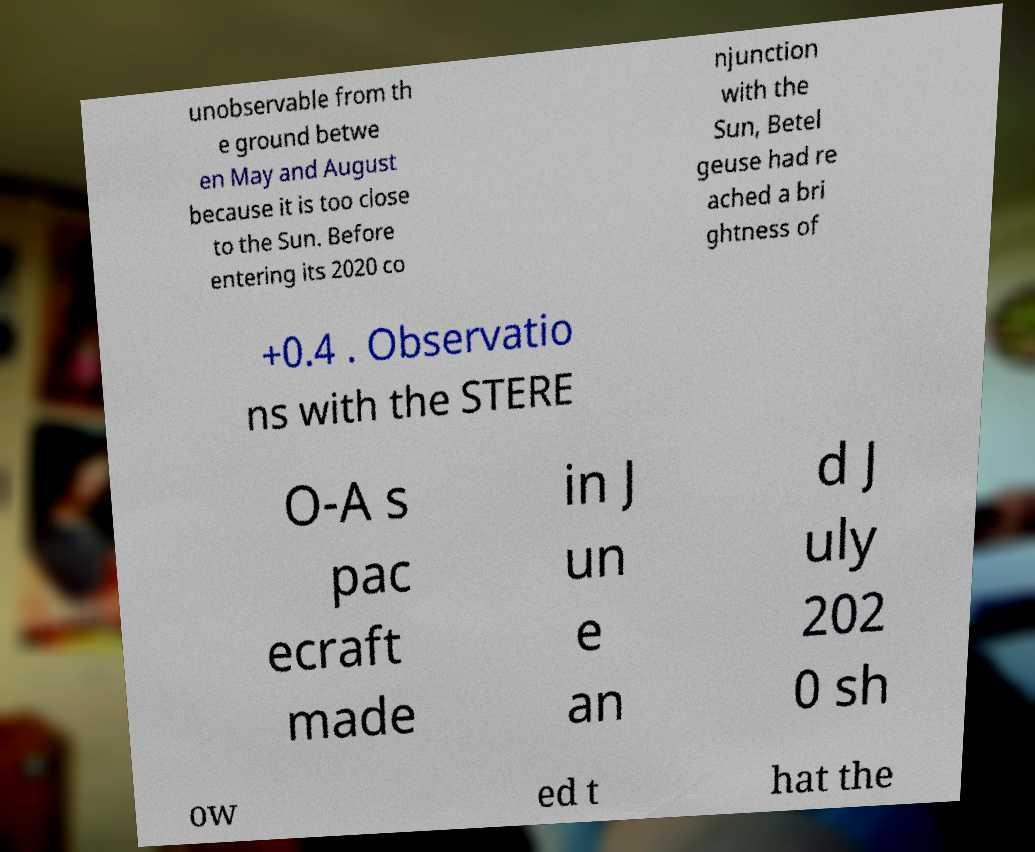Please read and relay the text visible in this image. What does it say? unobservable from th e ground betwe en May and August because it is too close to the Sun. Before entering its 2020 co njunction with the Sun, Betel geuse had re ached a bri ghtness of +0.4 . Observatio ns with the STERE O-A s pac ecraft made in J un e an d J uly 202 0 sh ow ed t hat the 